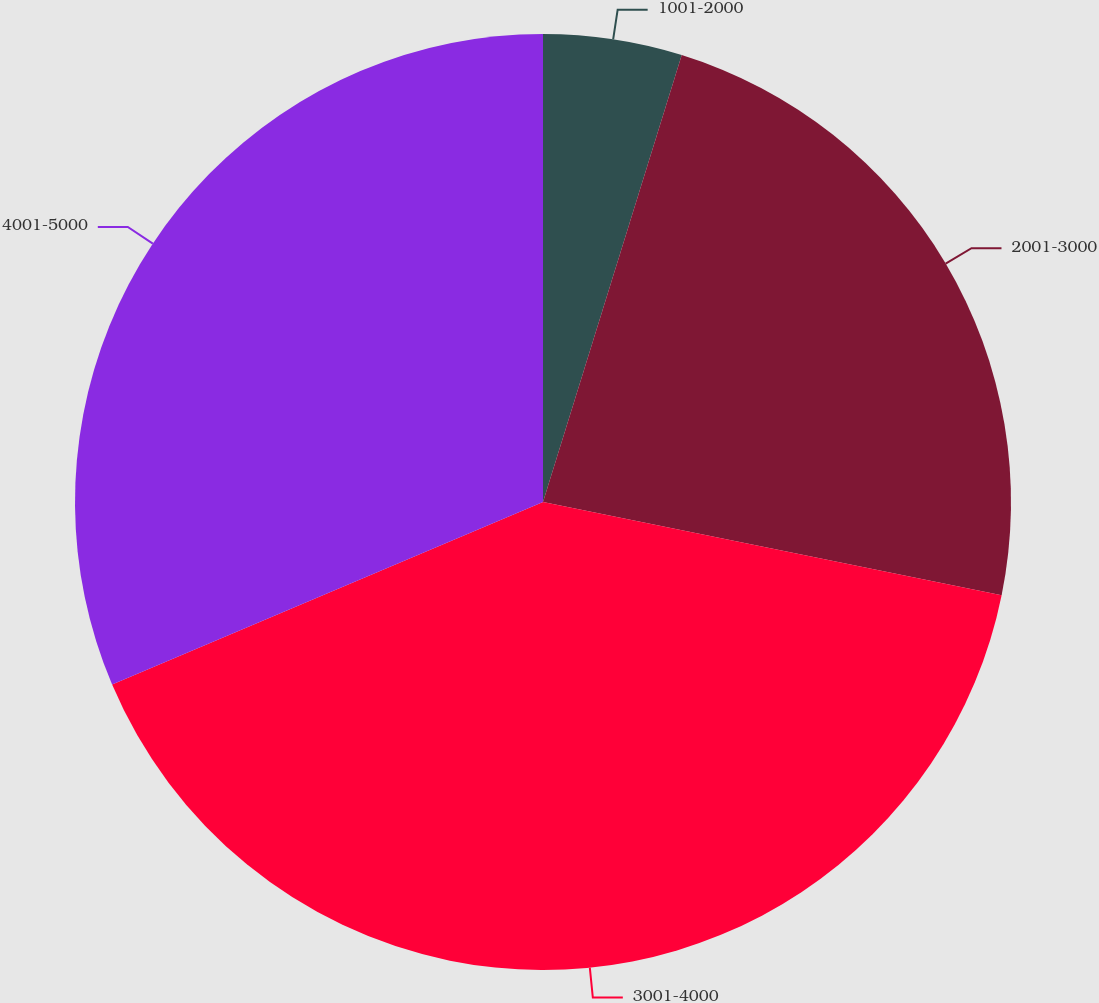<chart> <loc_0><loc_0><loc_500><loc_500><pie_chart><fcel>1001-2000<fcel>2001-3000<fcel>3001-4000<fcel>4001-5000<nl><fcel>4.79%<fcel>23.4%<fcel>40.43%<fcel>31.38%<nl></chart> 